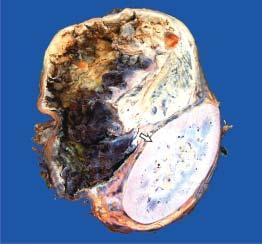what does the upper end show?
Answer the question using a single word or phrase. A large spherical tumour separate from the kidney 